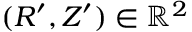<formula> <loc_0><loc_0><loc_500><loc_500>( R ^ { \prime } , Z ^ { \prime } ) \in \mathbb { R } ^ { 2 }</formula> 